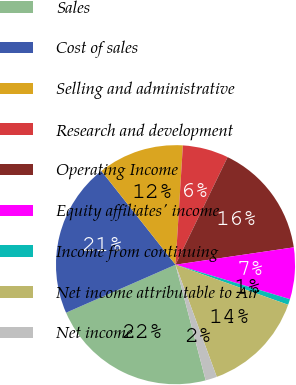Convert chart to OTSL. <chart><loc_0><loc_0><loc_500><loc_500><pie_chart><fcel>Sales<fcel>Cost of sales<fcel>Selling and administrative<fcel>Research and development<fcel>Operating Income<fcel>Equity affiliates' income<fcel>Income from continuing<fcel>Net income attributable to Air<fcel>Net income<nl><fcel>22.48%<fcel>20.93%<fcel>11.63%<fcel>6.2%<fcel>15.5%<fcel>6.98%<fcel>0.78%<fcel>13.95%<fcel>1.55%<nl></chart> 